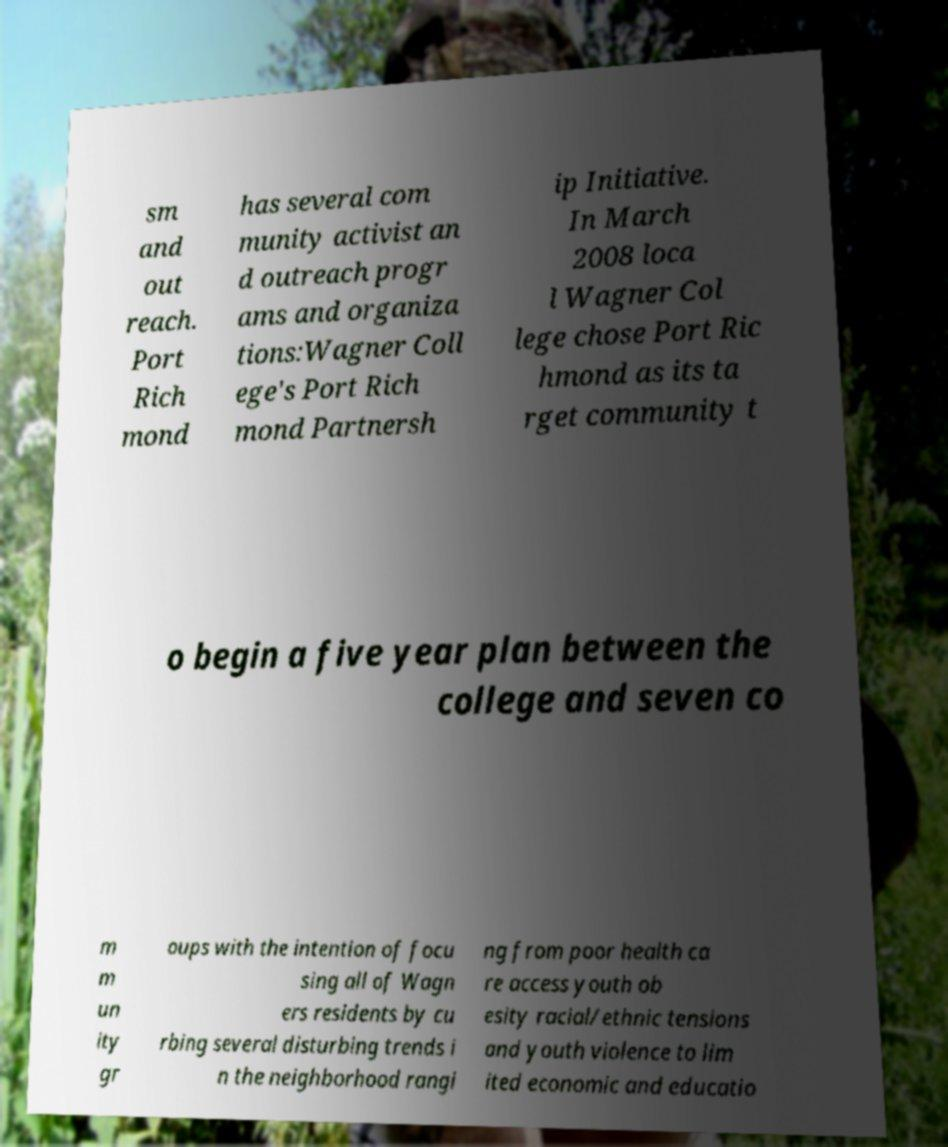Can you accurately transcribe the text from the provided image for me? sm and out reach. Port Rich mond has several com munity activist an d outreach progr ams and organiza tions:Wagner Coll ege's Port Rich mond Partnersh ip Initiative. In March 2008 loca l Wagner Col lege chose Port Ric hmond as its ta rget community t o begin a five year plan between the college and seven co m m un ity gr oups with the intention of focu sing all of Wagn ers residents by cu rbing several disturbing trends i n the neighborhood rangi ng from poor health ca re access youth ob esity racial/ethnic tensions and youth violence to lim ited economic and educatio 